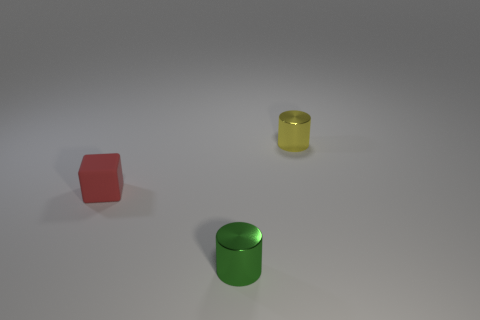Can you describe the shapes and their colors depicted in the image? Certainly! The image features three geometric shapes. On the left, there's a red cube with a matte finish. In the center, there's a medium-sized green cylinder with a shiny surface. On the right, a smaller, possibly transparent yellow cylinder can also be seen. They're placed against a neutral gray backdrop. 